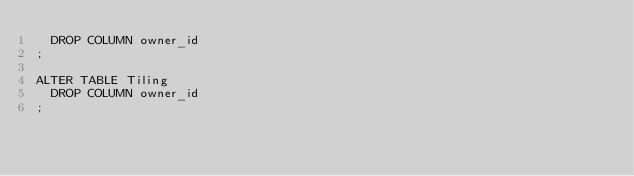<code> <loc_0><loc_0><loc_500><loc_500><_SQL_>  DROP COLUMN owner_id
;

ALTER TABLE Tiling
  DROP COLUMN owner_id
;
</code> 